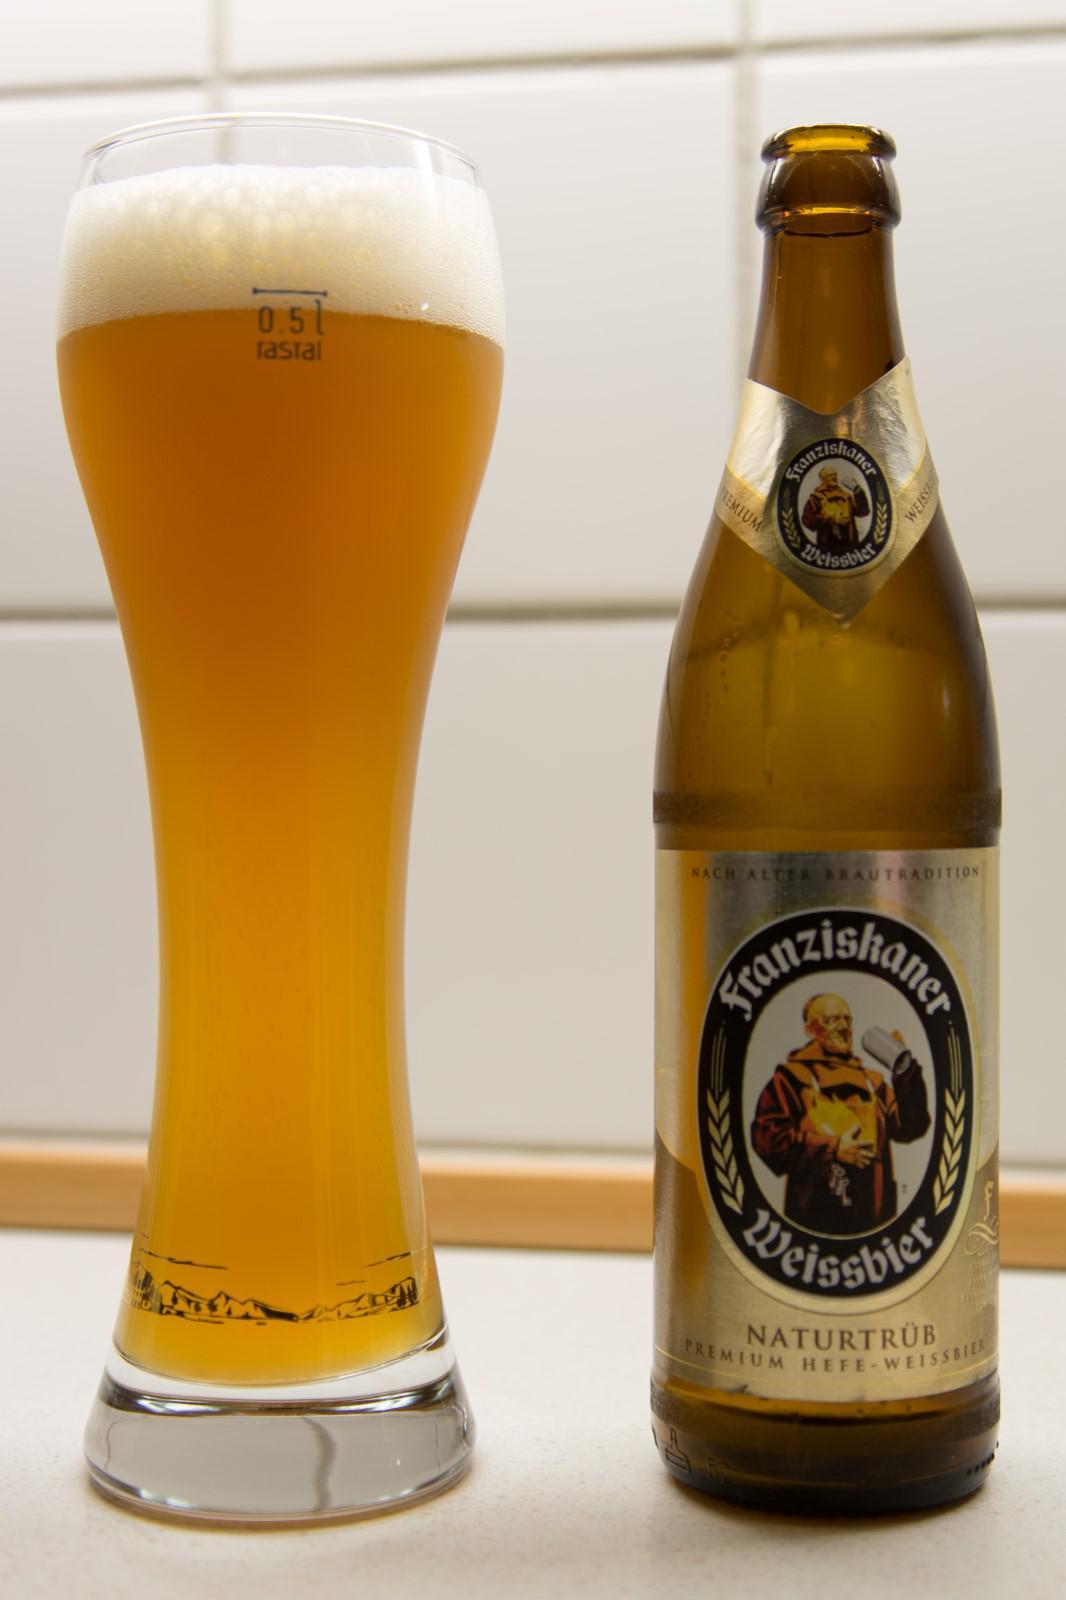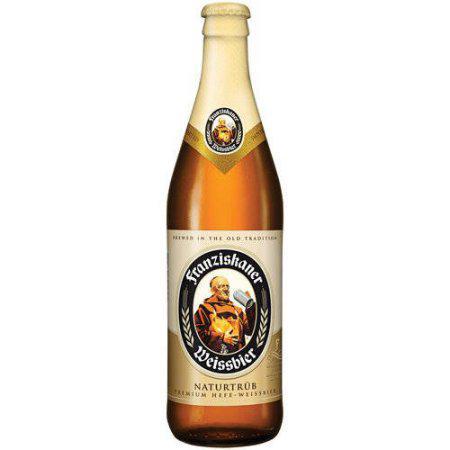The first image is the image on the left, the second image is the image on the right. For the images shown, is this caption "The left image contains both a bottle and a glass." true? Answer yes or no. Yes. The first image is the image on the left, the second image is the image on the right. Evaluate the accuracy of this statement regarding the images: "In one image, a glass of ale is sitting next to a bottle of ale.". Is it true? Answer yes or no. Yes. 